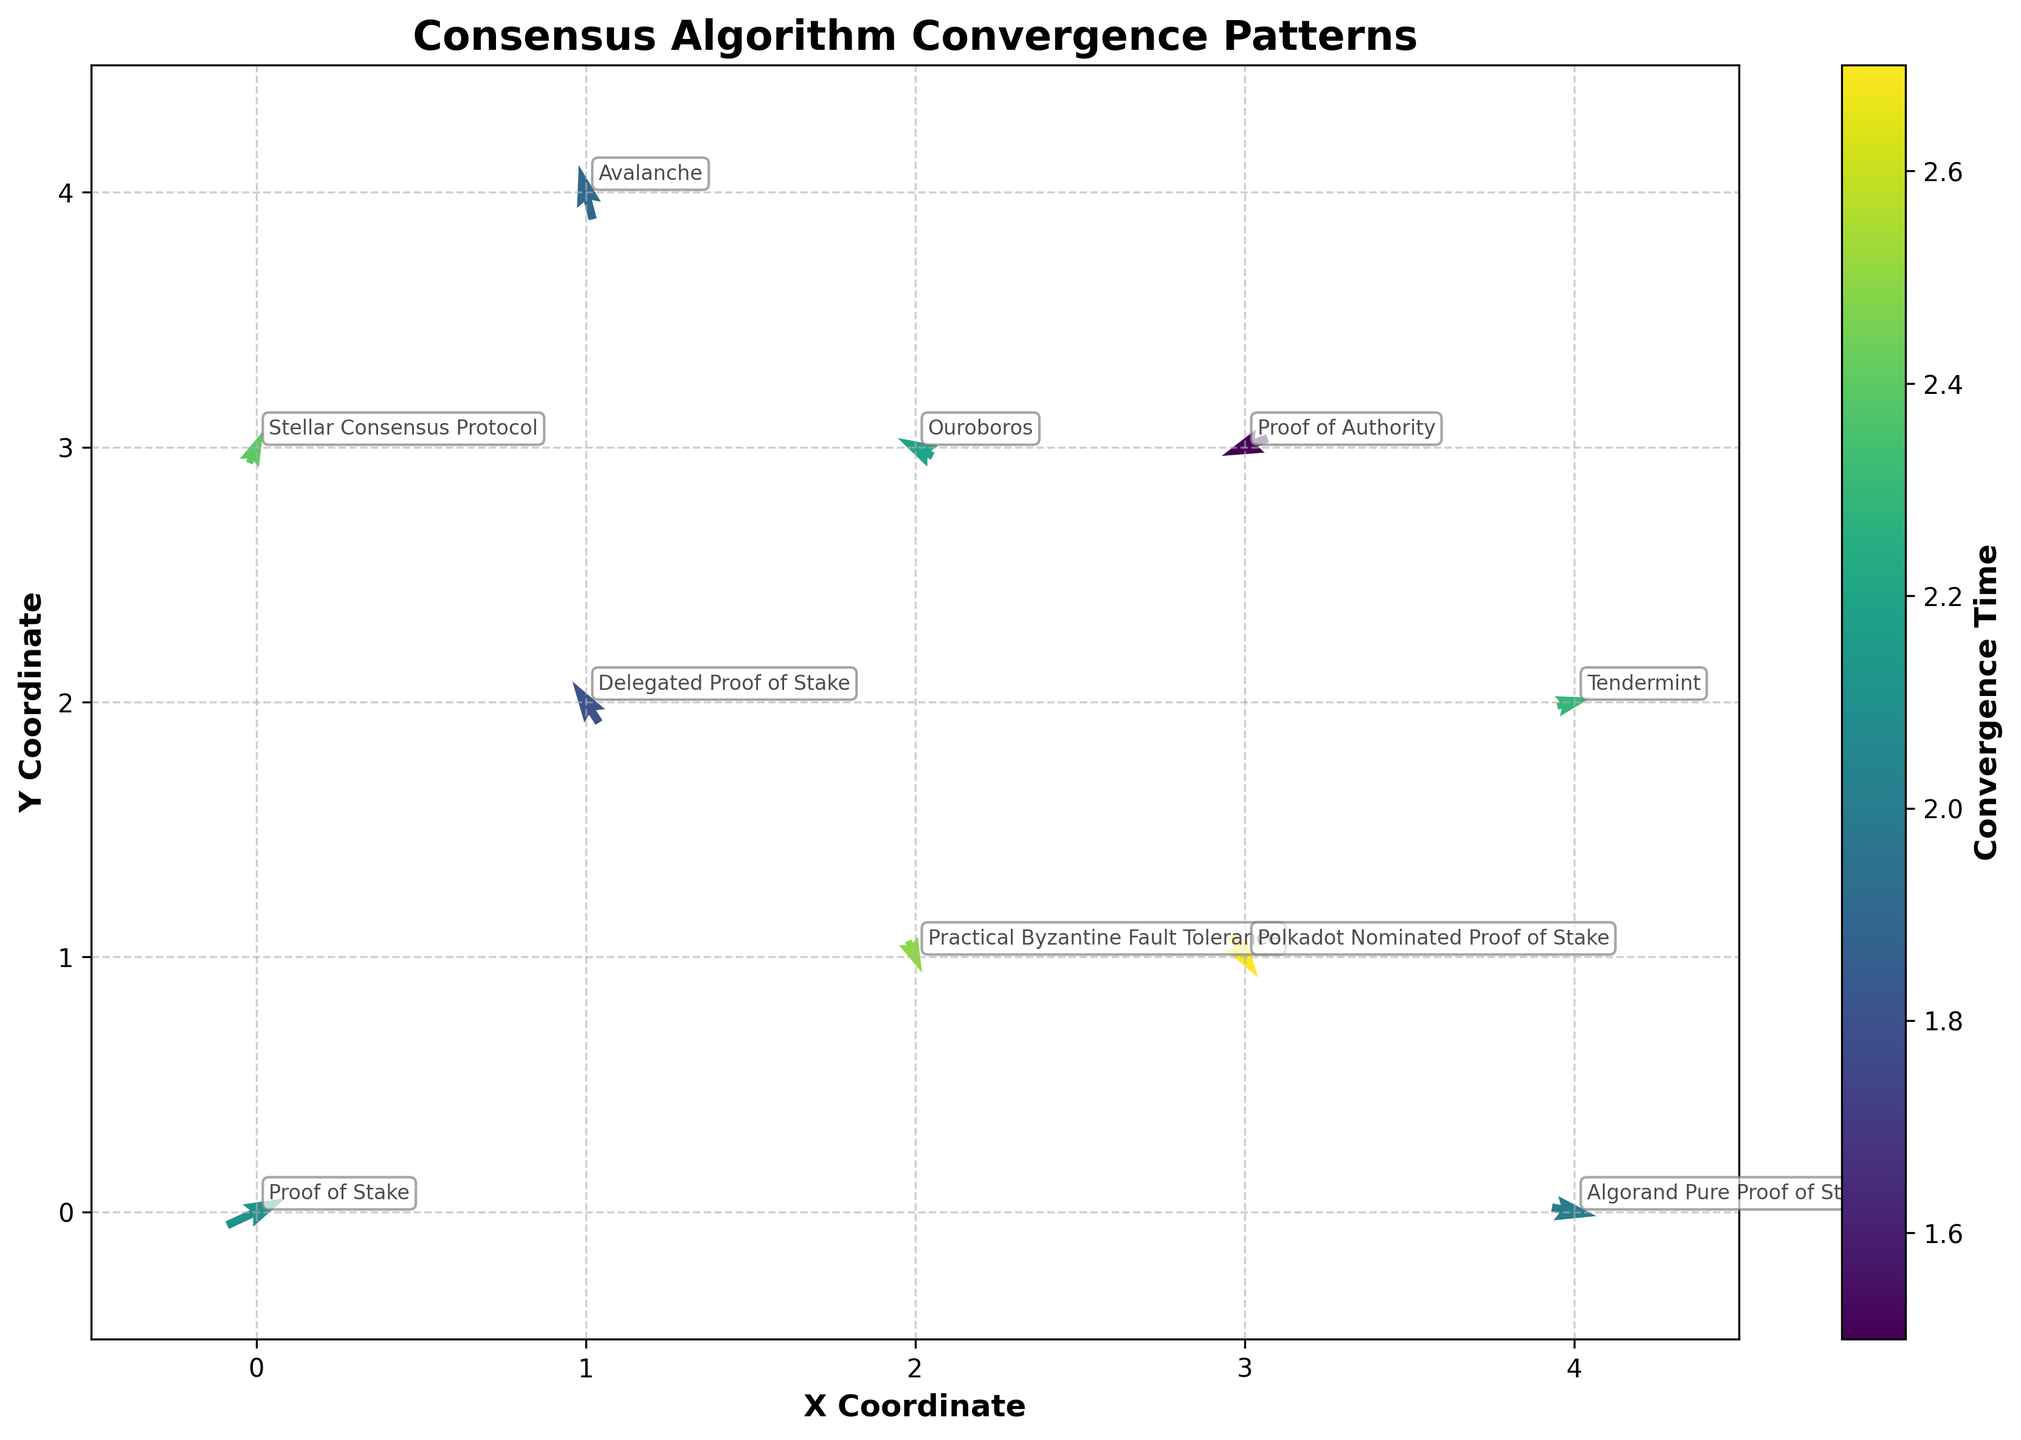What is the title of the quiver plot? The title of the plot is typically located at the top, centered above the figure. From the provided code, the title is "Consensus Algorithm Convergence Patterns"
Answer: Consensus Algorithm Convergence Patterns How many data points are shown in the plot? Each data point corresponds to a unique (X, Y) coordinate, and there are 10 such coordinates in the dataset.
Answer: 10 Which algorithm has the highest convergence time and what is its direction of movement? From the color coding of convergence times, the color bar indicates the highest value. The algorithm with the highest convergence time (2.7) is "Polkadot Nominated Proof of Stake", and its movement direction can be inferred from its U and V values.
Answer: Polkadot Nominated Proof of Stake, Upward and to the right What colors correspond to the shortest and longest convergence times? The color bar indicates colors scale from shortest to longest convergence time. Generally, lighter colors represent shorter times and darker colors represent longer times.
Answer: Light Yellow (shortest), Dark Blue (longest) Which algorithm's vector indicates a movement to the bottom-left direction? The vector indicating bottom-left movement would have negative U and V values. In the data, "Proof of Authority" has U=-0.4 and V=-0.2.
Answer: Proof of Authority Compare the convergence times of "Proof of Stake" and "Avalanche". Which one converges faster? By comparing the convergence times of the two algorithms, "Proof of Stake" has a convergence time of 2.1 while "Avalanche" has 1.9, indicating "Avalanche" converges faster.
Answer: Avalanche What is the average convergence time for all the algorithms shown? Sum all convergence times and divide by the number of algorithms: \( (2.1 + 1.8 + 2.5 + 1.5 + 2.3 + 1.9 + 2.7 + 2.2 + 2.0 + 2.4)/10 = 21.4/10 = 2.14 \).
Answer: 2.14 Which algorithm is located at the coordinate (4,2), and what direction does its vector point? From the data, the algorithm located at (4,2) is "Tendermint", and its direction indicated by U=0.3 and V=0.1 points upward and to the right.
Answer: Tendermint, Upward and to the right What is the average X coordinate for all the algorithms? The sum of the X coordinates is \(0 + 1 + 2 + 3 + 4 + 1 + 3 + 2 + 4 + 0 = 20\); dividing by the number of data points (10) gives an average of \(20/10 = 2\).
Answer: 2 Which algorithm has the smallest U vector component, and what is its value? The smallest U component is found by comparing all U values, and "Delegated Proof of Stake" has the smallest U value of -0.2.
Answer: Delegated Proof of Stake, -0.2 